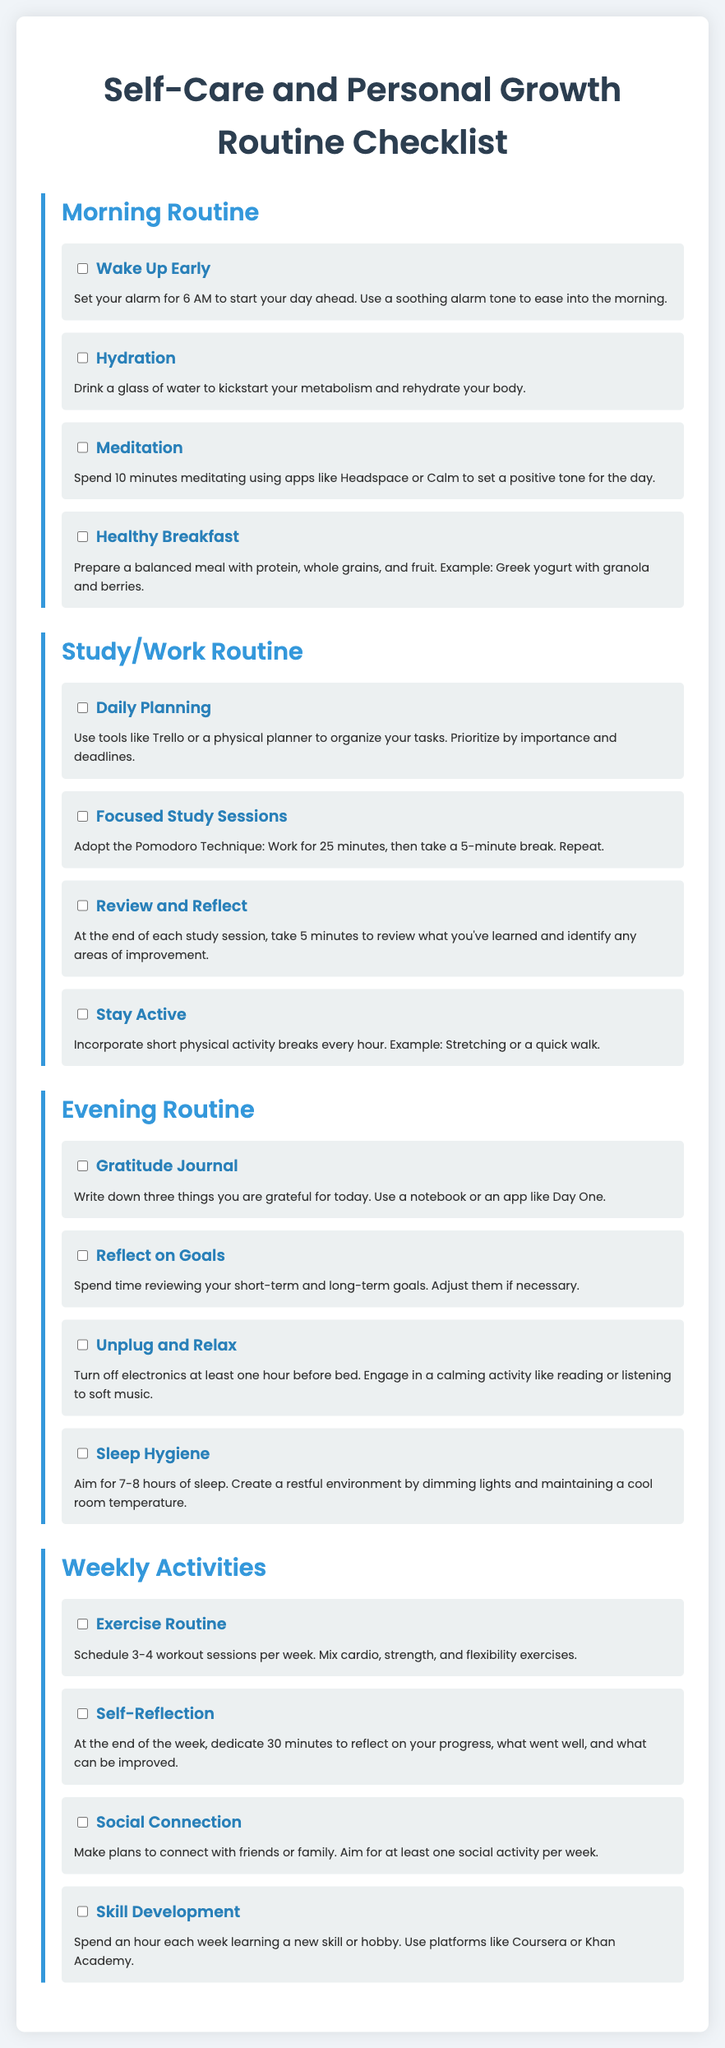what time should you wake up early? The document suggests setting the alarm for 6 AM to start your day ahead.
Answer: 6 AM how many minutes should you meditate in the morning? The document states to spend 10 minutes meditating using apps like Headspace or Calm.
Answer: 10 minutes what technique is suggested for focused study sessions? The document recommends the Pomodoro Technique, which involves working for 25 minutes, then taking a 5-minute break.
Answer: Pomodoro Technique what should you write in the gratitude journal? The document prompts you to write down three things you are grateful for today.
Answer: Three things how many workout sessions are recommended per week? The document advises to schedule 3-4 workout sessions per week.
Answer: 3-4 sessions what is the purpose of the self-reflection activity? The document states it is for reflecting on your progress, what went well, and what can be improved.
Answer: Reflecting on progress what should you do an hour before bed? The document suggests turning off electronics and engaging in a calming activity.
Answer: Turn off electronics how often should you connect with friends or family? The document mentions aiming for at least one social activity per week.
Answer: At least once a week 